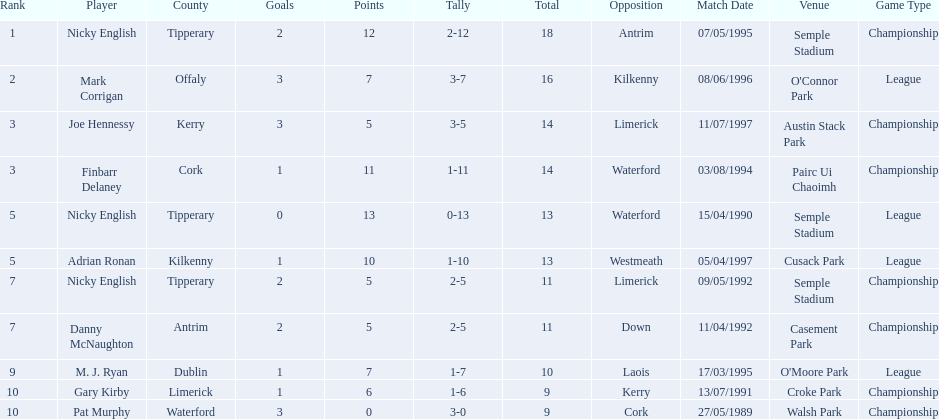Parse the table in full. {'header': ['Rank', 'Player', 'County', 'Goals', 'Points', 'Tally', 'Total', 'Opposition', 'Match Date', 'Venue', 'Game Type'], 'rows': [['1', 'Nicky English', 'Tipperary', '2', '12', '2-12', '18', 'Antrim', '07/05/1995', 'Semple Stadium', 'Championship'], ['2', 'Mark Corrigan', 'Offaly', '3', '7', '3-7', '16', 'Kilkenny', '08/06/1996', "O'Connor Park", 'League'], ['3', 'Joe Hennessy', 'Kerry', '3', '5', '3-5', '14', 'Limerick', '11/07/1997', 'Austin Stack Park', 'Championship'], ['3', 'Finbarr Delaney', 'Cork', '1', '11', '1-11', '14', 'Waterford', '03/08/1994', 'Pairc Ui Chaoimh', 'Championship'], ['5', 'Nicky English', 'Tipperary', '0', '13', '0-13', '13', 'Waterford', '15/04/1990', 'Semple Stadium', 'League'], ['5', 'Adrian Ronan', 'Kilkenny', '1', '10', '1-10', '13', 'Westmeath', '05/04/1997', 'Cusack Park', 'League'], ['7', 'Nicky English', 'Tipperary', '2', '5', '2-5', '11', 'Limerick', '09/05/1992', 'Semple Stadium', 'Championship'], ['7', 'Danny McNaughton', 'Antrim', '2', '5', '2-5', '11', 'Down', '11/04/1992', 'Casement Park', 'Championship'], ['9', 'M. J. Ryan', 'Dublin', '1', '7', '1-7', '10', 'Laois', '17/03/1995', "O'Moore Park", 'League'], ['10', 'Gary Kirby', 'Limerick', '1', '6', '1-6', '9', 'Kerry', '13/07/1991', 'Croke Park', 'Championship'], ['10', 'Pat Murphy', 'Waterford', '3', '0', '3-0', '9', 'Cork', '27/05/1989', 'Walsh Park', 'Championship']]} Which of the following players were ranked in the bottom 5? Nicky English, Danny McNaughton, M. J. Ryan, Gary Kirby, Pat Murphy. Of these, whose tallies were not 2-5? M. J. Ryan, Gary Kirby, Pat Murphy. From the above three, which one scored more than 9 total points? M. J. Ryan. 